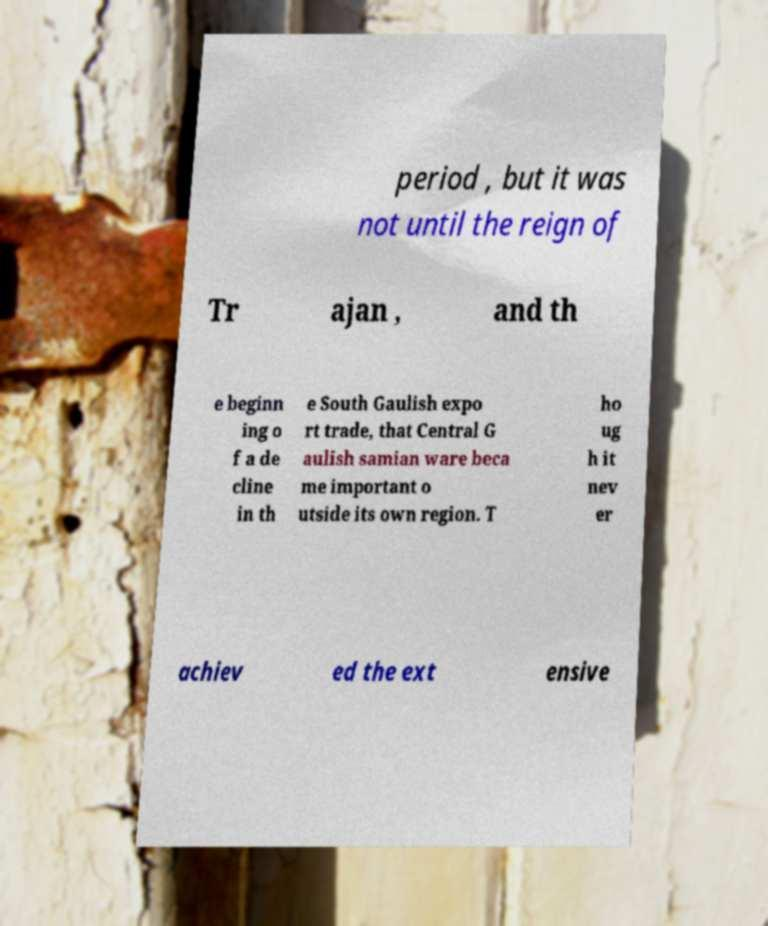There's text embedded in this image that I need extracted. Can you transcribe it verbatim? period , but it was not until the reign of Tr ajan , and th e beginn ing o f a de cline in th e South Gaulish expo rt trade, that Central G aulish samian ware beca me important o utside its own region. T ho ug h it nev er achiev ed the ext ensive 